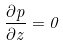<formula> <loc_0><loc_0><loc_500><loc_500>\frac { \partial p } { \partial z } = 0</formula> 